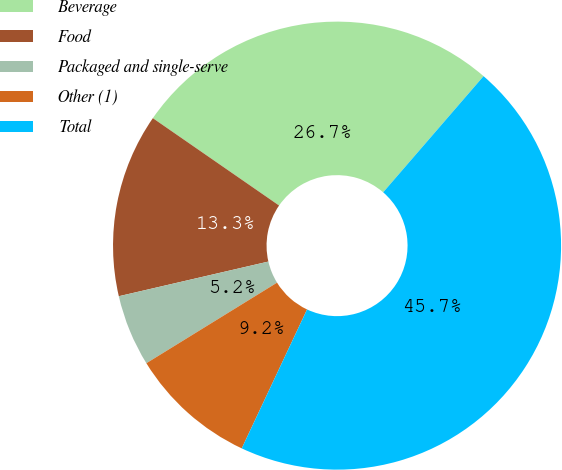Convert chart to OTSL. <chart><loc_0><loc_0><loc_500><loc_500><pie_chart><fcel>Beverage<fcel>Food<fcel>Packaged and single-serve<fcel>Other (1)<fcel>Total<nl><fcel>26.71%<fcel>13.26%<fcel>5.17%<fcel>9.21%<fcel>45.65%<nl></chart> 